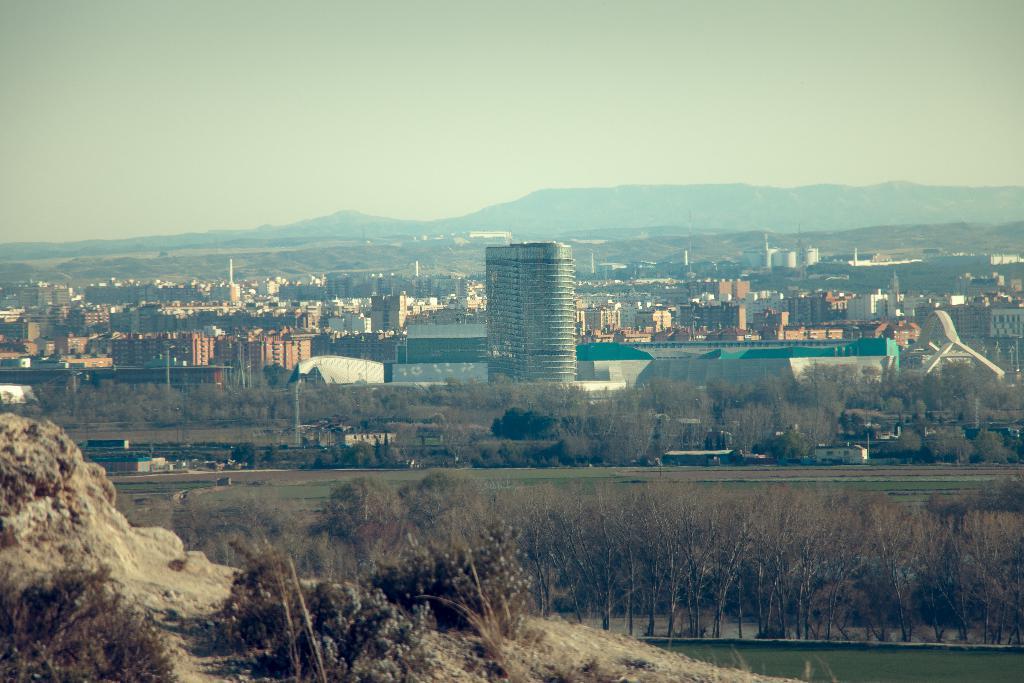Could you give a brief overview of what you see in this image? In this image we can see buildings, poles, trees, plants, grass, and the mud, also we can see the sky. 